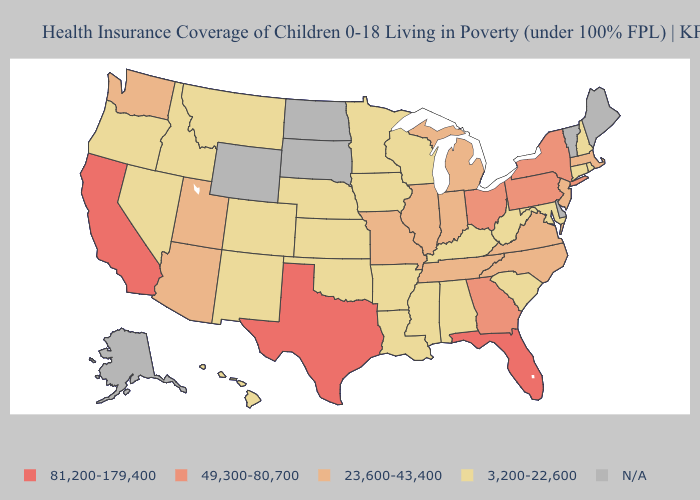What is the highest value in states that border California?
Write a very short answer. 23,600-43,400. What is the highest value in the Northeast ?
Give a very brief answer. 49,300-80,700. Among the states that border Indiana , which have the highest value?
Give a very brief answer. Ohio. What is the highest value in states that border Virginia?
Write a very short answer. 23,600-43,400. Name the states that have a value in the range 3,200-22,600?
Be succinct. Alabama, Arkansas, Colorado, Connecticut, Hawaii, Idaho, Iowa, Kansas, Kentucky, Louisiana, Maryland, Minnesota, Mississippi, Montana, Nebraska, Nevada, New Hampshire, New Mexico, Oklahoma, Oregon, Rhode Island, South Carolina, West Virginia, Wisconsin. What is the value of New Jersey?
Quick response, please. 23,600-43,400. What is the highest value in states that border Ohio?
Give a very brief answer. 49,300-80,700. Name the states that have a value in the range 81,200-179,400?
Answer briefly. California, Florida, Texas. Which states have the lowest value in the USA?
Keep it brief. Alabama, Arkansas, Colorado, Connecticut, Hawaii, Idaho, Iowa, Kansas, Kentucky, Louisiana, Maryland, Minnesota, Mississippi, Montana, Nebraska, Nevada, New Hampshire, New Mexico, Oklahoma, Oregon, Rhode Island, South Carolina, West Virginia, Wisconsin. Does Virginia have the highest value in the South?
Write a very short answer. No. Name the states that have a value in the range 81,200-179,400?
Short answer required. California, Florida, Texas. What is the value of New Mexico?
Give a very brief answer. 3,200-22,600. What is the value of California?
Give a very brief answer. 81,200-179,400. 